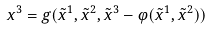<formula> <loc_0><loc_0><loc_500><loc_500>x ^ { 3 } = g ( \tilde { x } ^ { 1 } , \tilde { x } ^ { 2 } , \tilde { x } ^ { 3 } - \varphi ( \tilde { x } ^ { 1 } , \tilde { x } ^ { 2 } ) )</formula> 